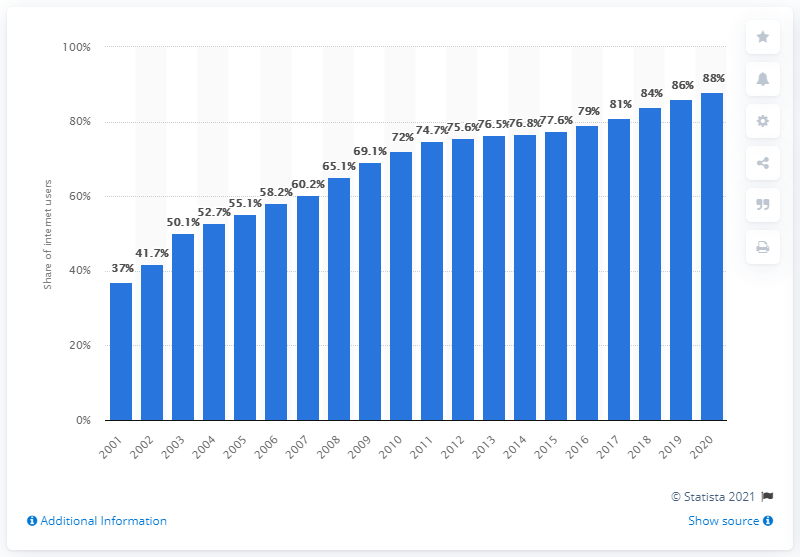Outline some significant characteristics in this image. In 2020, approximately 88% of German internet users were present online. 